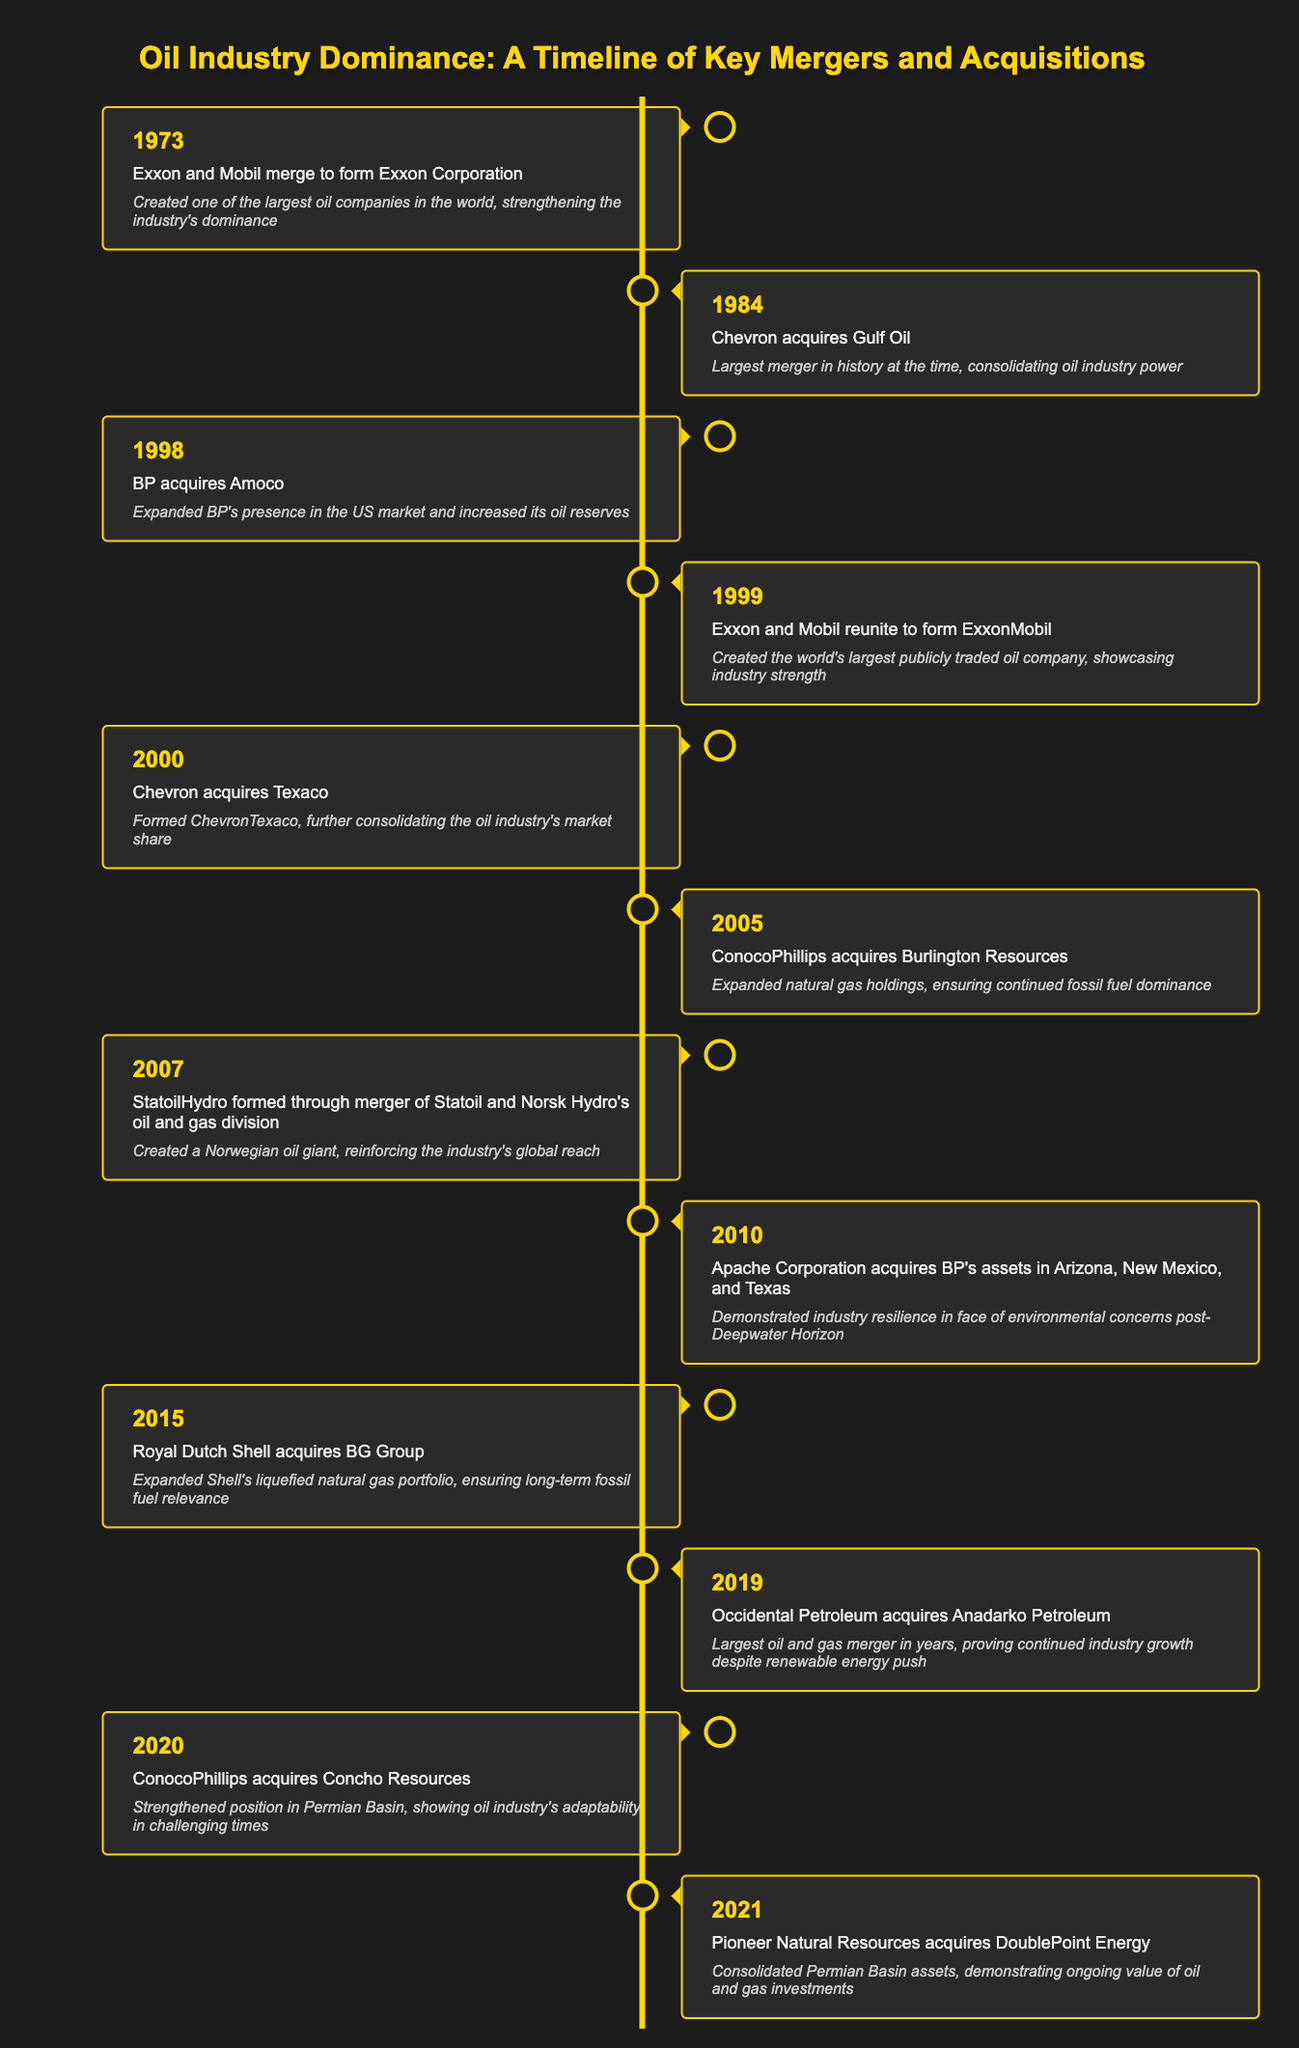What significant merger occurred in 1984? The table indicates that in 1984, Chevron acquired Gulf Oil, which was the largest merger in history at that time.
Answer: Chevron acquires Gulf Oil What was the significance of the 1999 reunion of Exxon and Mobil? According to the table, the significance of the 1999 event where Exxon and Mobil reunited to form ExxonMobil was that it created the world's largest publicly traded oil company.
Answer: Created world's largest publicly traded oil company Did ConocoPhillips acquire Burlington Resources before or after 2005? The timeline shows that ConocoPhillips acquired Burlington Resources in 2005, indicating that this acquisition occurred in that year.
Answer: In 2005 Which acquisition is noted for demonstrating industry resilience after environmental concerns? In 2010, Apache Corporation's acquisition of BP's assets in Arizona, New Mexico, and Texas is noted for demonstrating industry resilience following the Deepwater Horizon incident.
Answer: Apache Corporation acquires BP's assets in 2010 What was the last merger listed in the timeline? The most recent merger in the timeline is Pioneer Natural Resources' acquisition of DoublePoint Energy in 2021.
Answer: Pioneer Natural Resources acquires DoublePoint Energy in 2021 How many mergers mentioned involved Chevron? The timeline shows that Chevron was involved in three significant mergers: the acquisition of Gulf Oil in 1984, Texaco in 2000, and the formation of ChevronTexaco in the same year. Therefore, there are three mergers in total.
Answer: Three Was the acquisition of Anadarko Petroleum by Occidental Petroleum significant enough to be the largest in years? The table explicitly states that the acquisition of Anadarko Petroleum by Occidental Petroleum in 2019 was the largest oil and gas merger in years, indicating a strong significance.
Answer: Yes Considering the timeline, how did acquisitions reflect the oil industry's dominance over time? Multiple mergers and acquisitions across the decades show a trend of consolidation and growth in the oil sector, reflecting its dominance. Significant events like the reunification of Exxon and Mobil and the acquisition of BG Group by Shell highlight this trend over time.
Answer: Acquisitions reflect industry dominance through consolidation and growth 